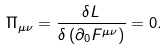Convert formula to latex. <formula><loc_0><loc_0><loc_500><loc_500>\Pi _ { \mu \nu } = \frac { \delta L } { \delta \left ( \partial _ { 0 } F ^ { \mu \nu } \right ) } = 0 .</formula> 